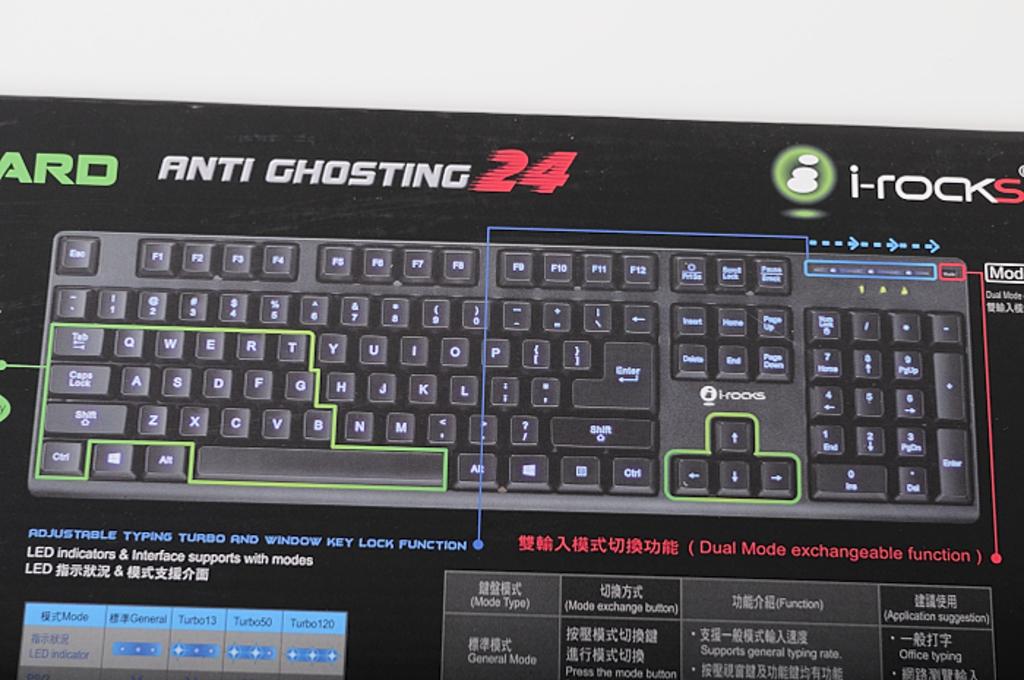What is the name of the keyboard?
Give a very brief answer. Anti ghosting 24. What model is the keyboard brand?
Provide a short and direct response. Anti ghosting 24. 